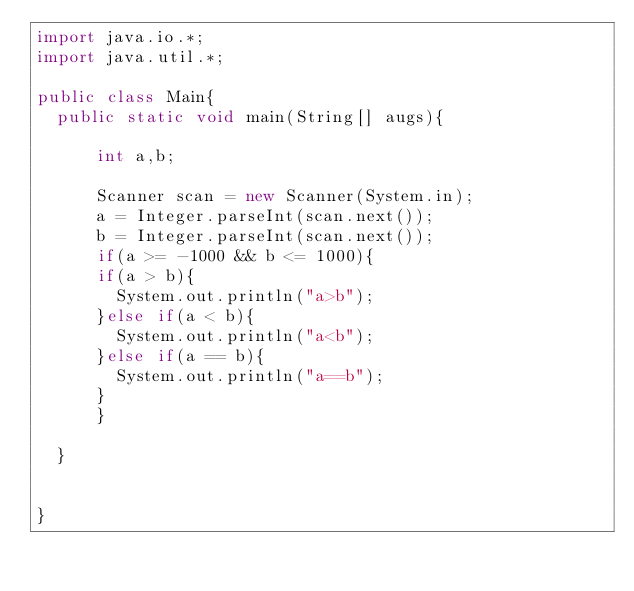Convert code to text. <code><loc_0><loc_0><loc_500><loc_500><_Java_>import java.io.*;
import java.util.*;

public class Main{
	public static void main(String[] augs){

	    int a,b;

	    Scanner scan = new Scanner(System.in);
	    a = Integer.parseInt(scan.next());
	    b = Integer.parseInt(scan.next());
	    if(a >= -1000 && b <= 1000){
	    if(a > b){
	    	System.out.println("a>b");
	    }else if(a < b){
	    	System.out.println("a<b");
	    }else if(a == b){
	    	System.out.println("a==b");
	    }
	    }
	
	}


}</code> 